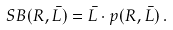<formula> <loc_0><loc_0><loc_500><loc_500>S B ( R , \bar { L } ) = \bar { L } \cdot p ( R , \bar { L } ) \, .</formula> 